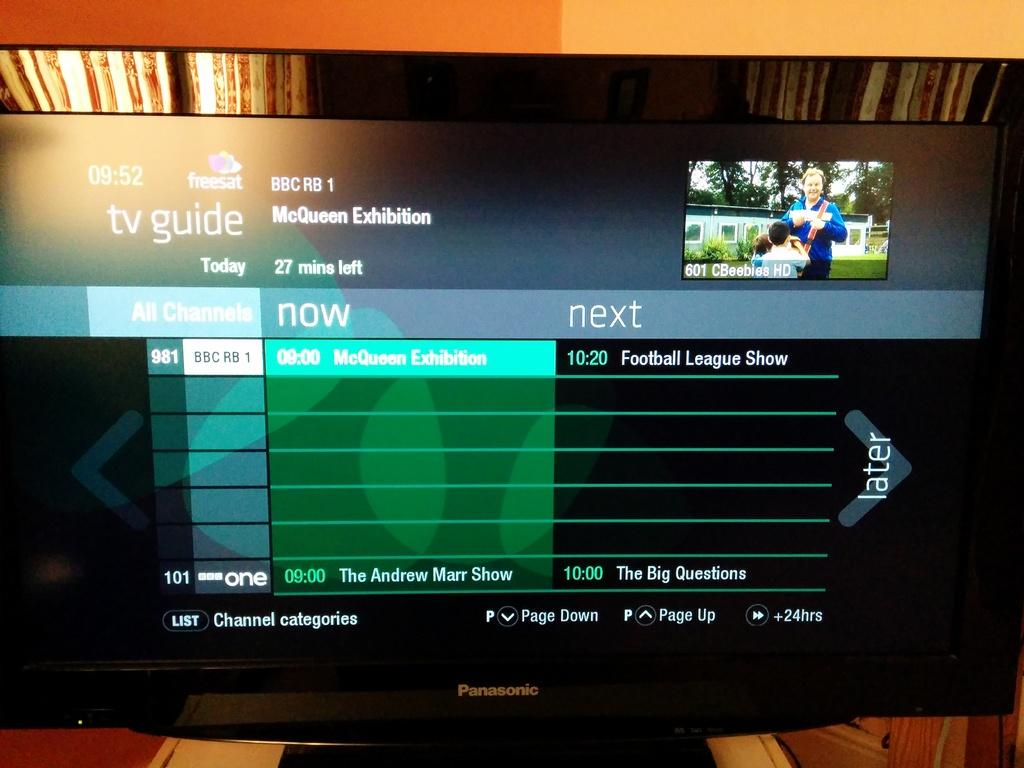<image>
Provide a brief description of the given image. a screen that has the word next on it 